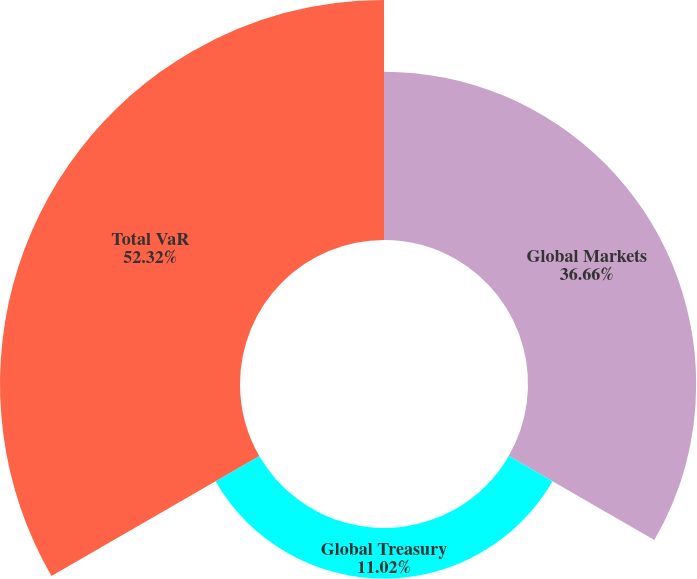<chart> <loc_0><loc_0><loc_500><loc_500><pie_chart><fcel>Global Markets<fcel>Global Treasury<fcel>Total VaR<nl><fcel>36.66%<fcel>11.02%<fcel>52.32%<nl></chart> 